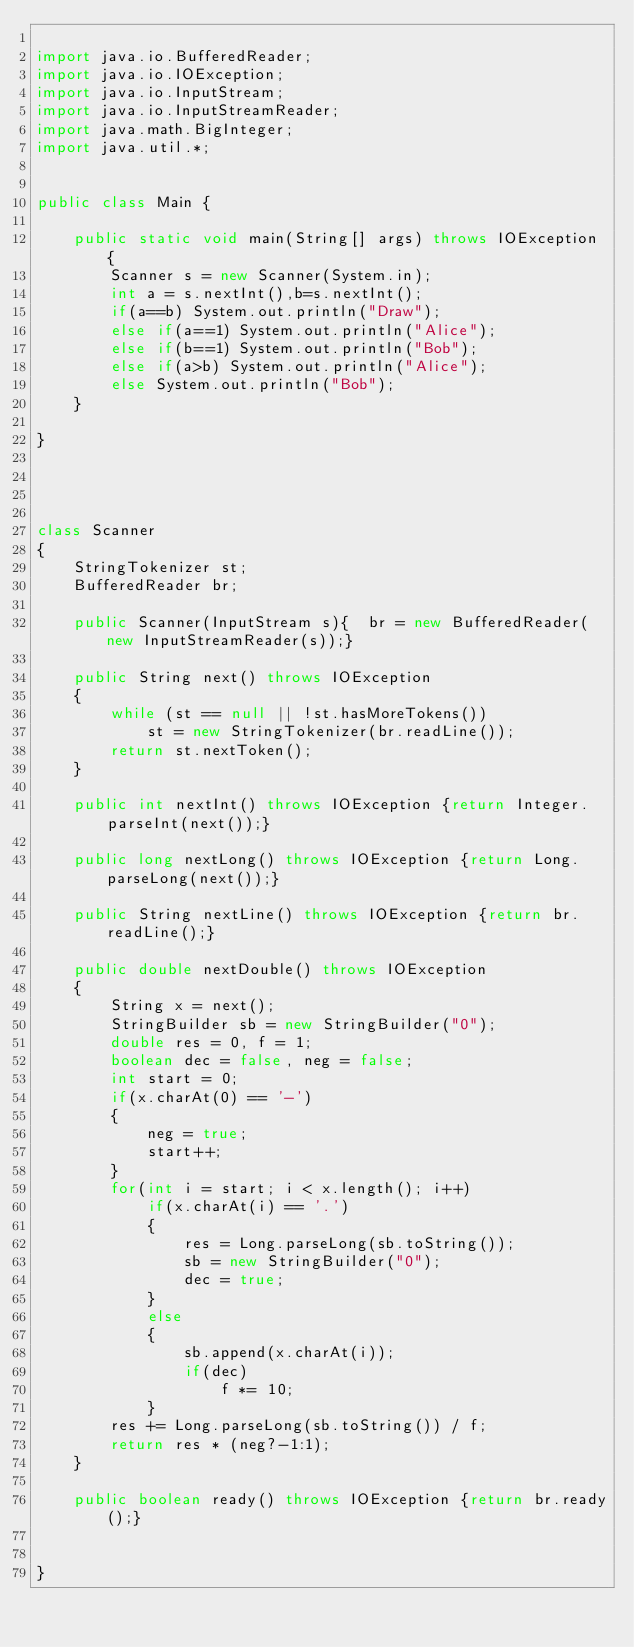<code> <loc_0><loc_0><loc_500><loc_500><_Java_>
import java.io.BufferedReader;
import java.io.IOException;
import java.io.InputStream;
import java.io.InputStreamReader;
import java.math.BigInteger;
import java.util.*;


public class Main {

    public static void main(String[] args) throws IOException {
        Scanner s = new Scanner(System.in);
        int a = s.nextInt(),b=s.nextInt();
        if(a==b) System.out.println("Draw");
        else if(a==1) System.out.println("Alice");
        else if(b==1) System.out.println("Bob");
        else if(a>b) System.out.println("Alice");
        else System.out.println("Bob");
    }

}




class Scanner
{
    StringTokenizer st;
    BufferedReader br;

    public Scanner(InputStream s){	br = new BufferedReader(new InputStreamReader(s));}

    public String next() throws IOException
    {
        while (st == null || !st.hasMoreTokens())
            st = new StringTokenizer(br.readLine());
        return st.nextToken();
    }

    public int nextInt() throws IOException {return Integer.parseInt(next());}

    public long nextLong() throws IOException {return Long.parseLong(next());}

    public String nextLine() throws IOException {return br.readLine();}

    public double nextDouble() throws IOException
    {
        String x = next();
        StringBuilder sb = new StringBuilder("0");
        double res = 0, f = 1;
        boolean dec = false, neg = false;
        int start = 0;
        if(x.charAt(0) == '-')
        {
            neg = true;
            start++;
        }
        for(int i = start; i < x.length(); i++)
            if(x.charAt(i) == '.')
            {
                res = Long.parseLong(sb.toString());
                sb = new StringBuilder("0");
                dec = true;
            }
            else
            {
                sb.append(x.charAt(i));
                if(dec)
                    f *= 10;
            }
        res += Long.parseLong(sb.toString()) / f;
        return res * (neg?-1:1);
    }

    public boolean ready() throws IOException {return br.ready();}


}</code> 